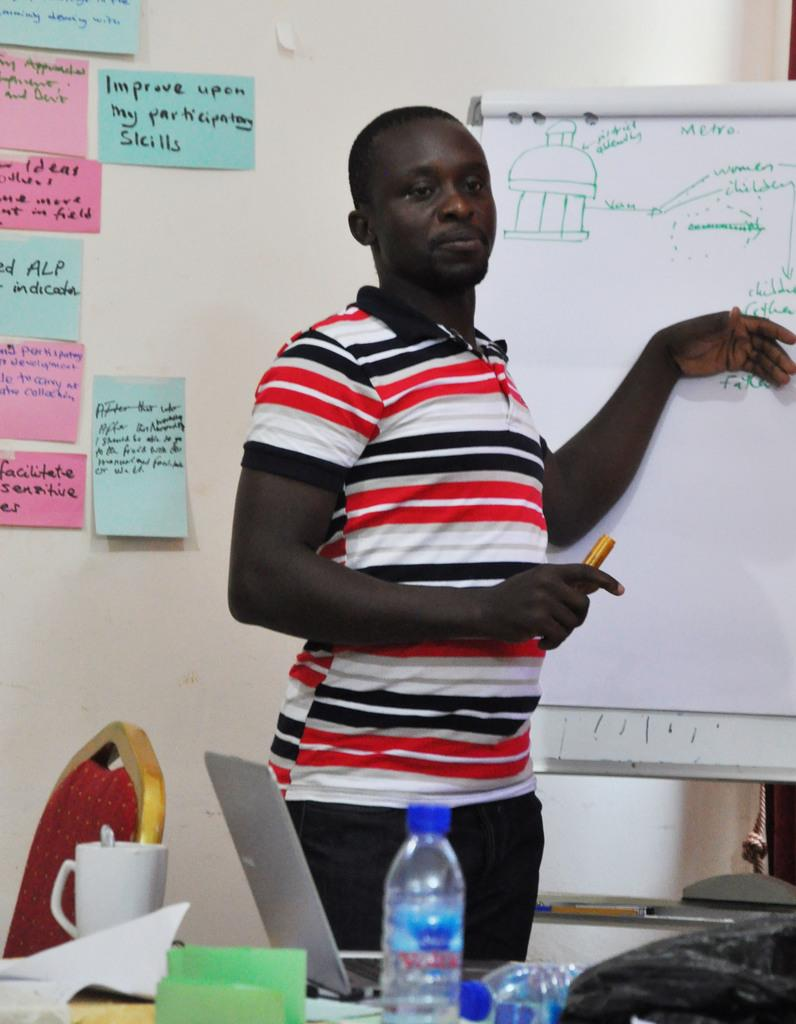<image>
Share a concise interpretation of the image provided. Improve upon my participation skills is wriiten on a poster hanging on the wall in the background. 